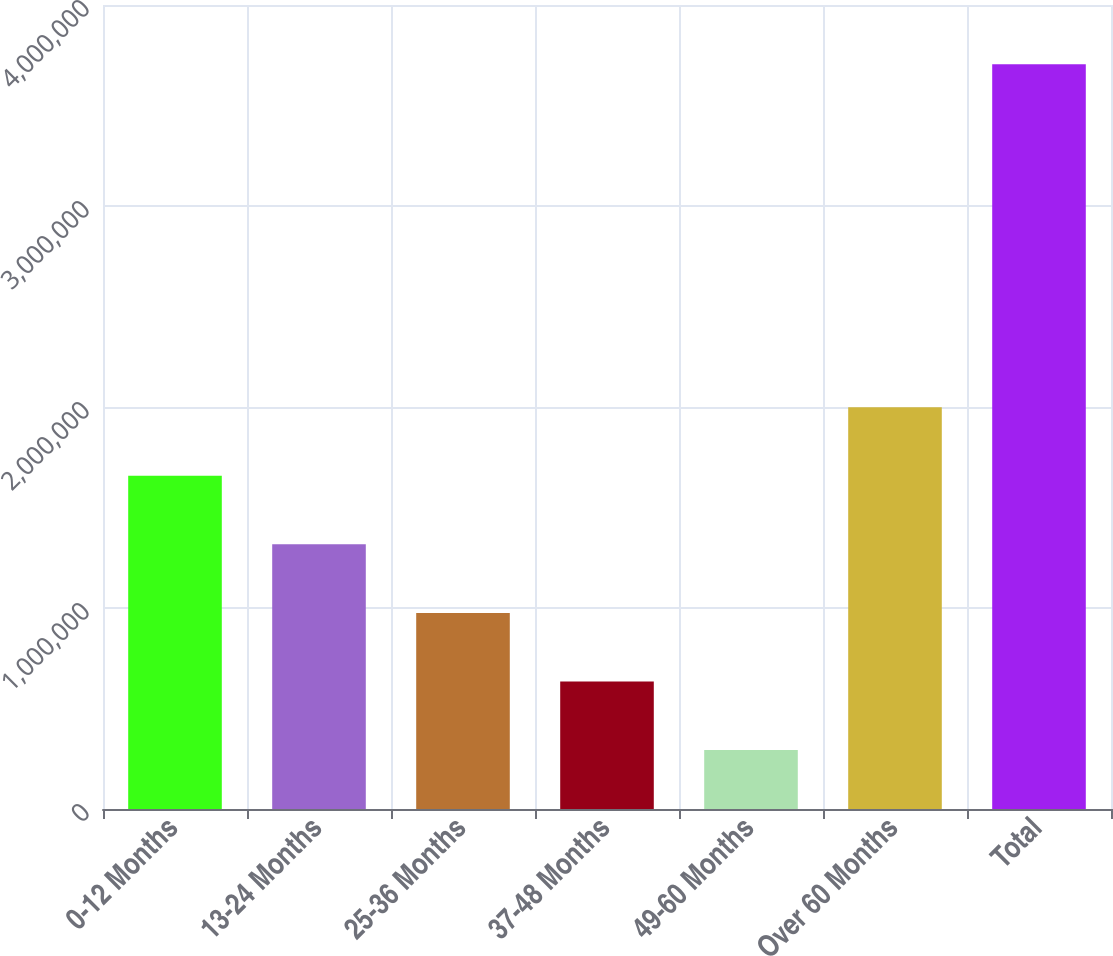Convert chart to OTSL. <chart><loc_0><loc_0><loc_500><loc_500><bar_chart><fcel>0-12 Months<fcel>13-24 Months<fcel>25-36 Months<fcel>37-48 Months<fcel>49-60 Months<fcel>Over 60 Months<fcel>Total<nl><fcel>1.6581e+06<fcel>1.31688e+06<fcel>975663<fcel>634442<fcel>293222<fcel>1.99932e+06<fcel>3.70542e+06<nl></chart> 